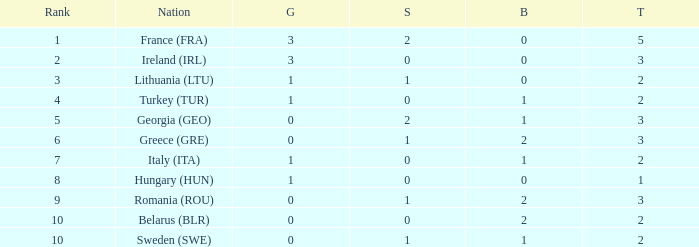What's the total number of bronze medals for Sweden (SWE) having less than 1 gold and silver? 0.0. 